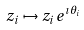Convert formula to latex. <formula><loc_0><loc_0><loc_500><loc_500>z _ { i } \mapsto z _ { i } e ^ { \imath \theta _ { i } }</formula> 